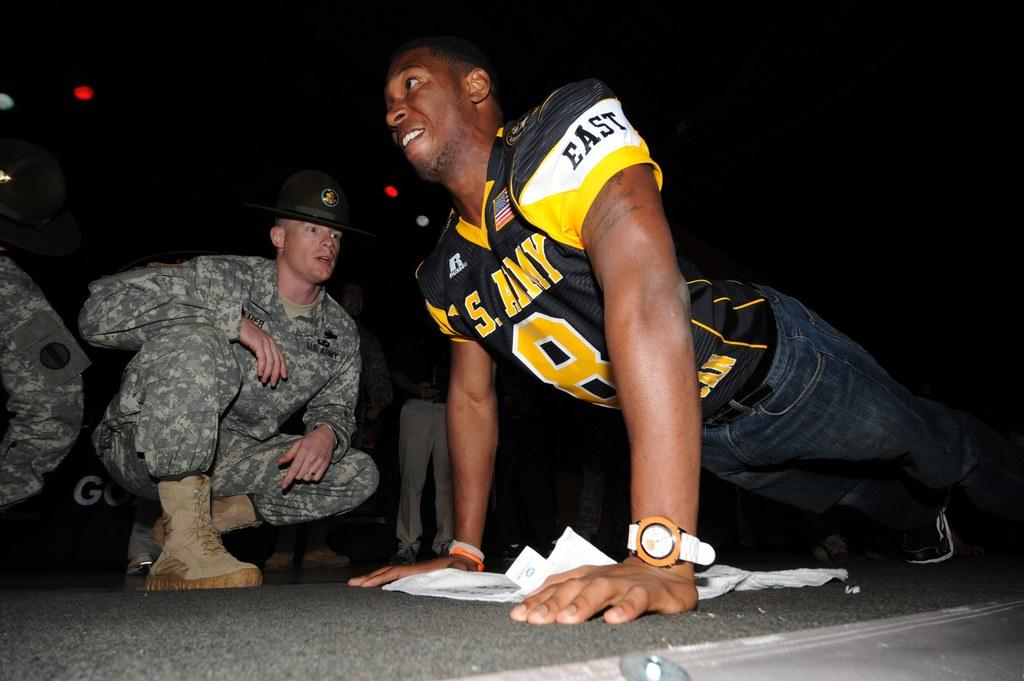<image>
Create a compact narrative representing the image presented. A man wearing a U.S. Army jersey is doing pushups in front of a drill sergeant. 